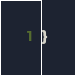Convert code to text. <code><loc_0><loc_0><loc_500><loc_500><_Scala_>}</code> 